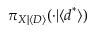Convert formula to latex. <formula><loc_0><loc_0><loc_500><loc_500>\pi _ { X | \langle D \rangle } ( \cdot | \langle d ^ { * } \rangle )</formula> 